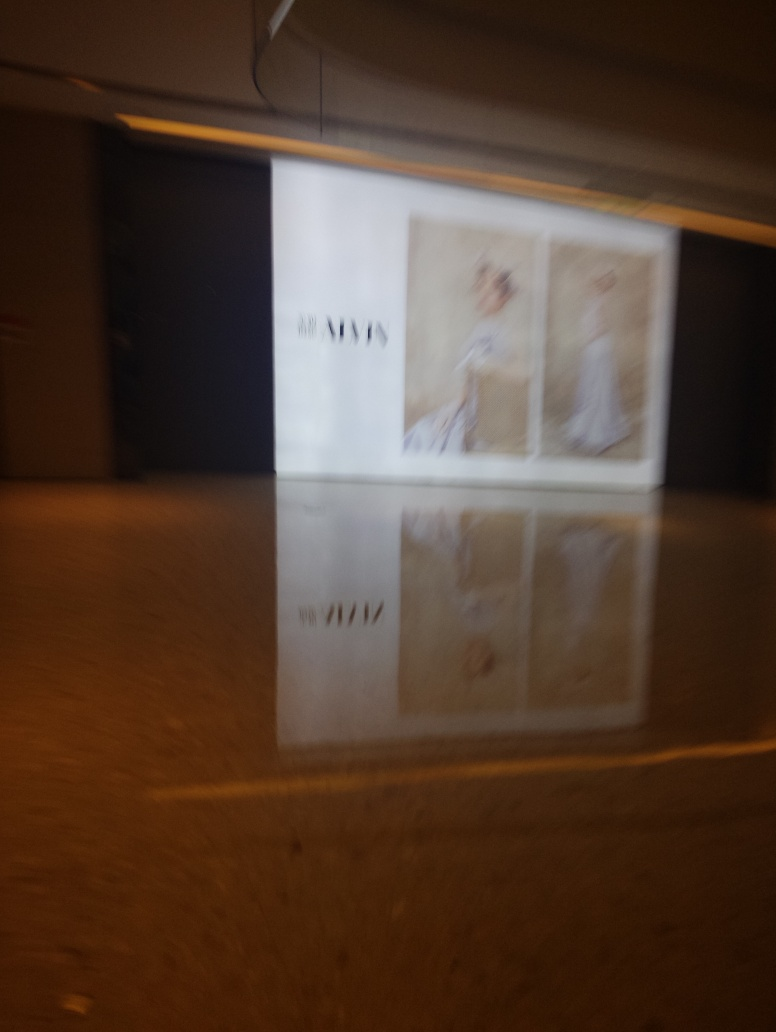Is the background blurry? Upon closer inspection of the image, it appears that the overall scene possesses a degree of motion-induced blur, which most likely affects the foreground and background uniformly. This results in the lack of sharpness that one might observe across the entire image. 